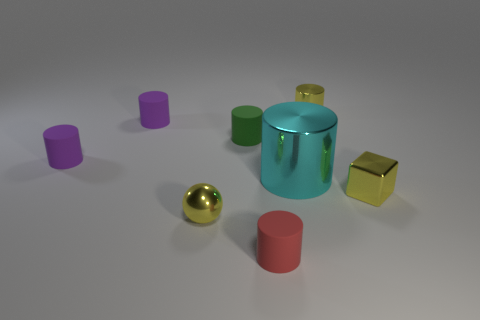Subtract 3 cylinders. How many cylinders are left? 3 Subtract all purple cylinders. How many cylinders are left? 4 Subtract all metal cylinders. How many cylinders are left? 4 Subtract all purple cylinders. Subtract all green cubes. How many cylinders are left? 4 Add 2 red things. How many objects exist? 10 Subtract all balls. How many objects are left? 7 Add 1 red matte objects. How many red matte objects are left? 2 Add 2 small brown matte things. How many small brown matte things exist? 2 Subtract 0 blue blocks. How many objects are left? 8 Subtract all large cyan shiny cylinders. Subtract all tiny matte cylinders. How many objects are left? 3 